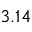<formula> <loc_0><loc_0><loc_500><loc_500>3 . 1 4</formula> 